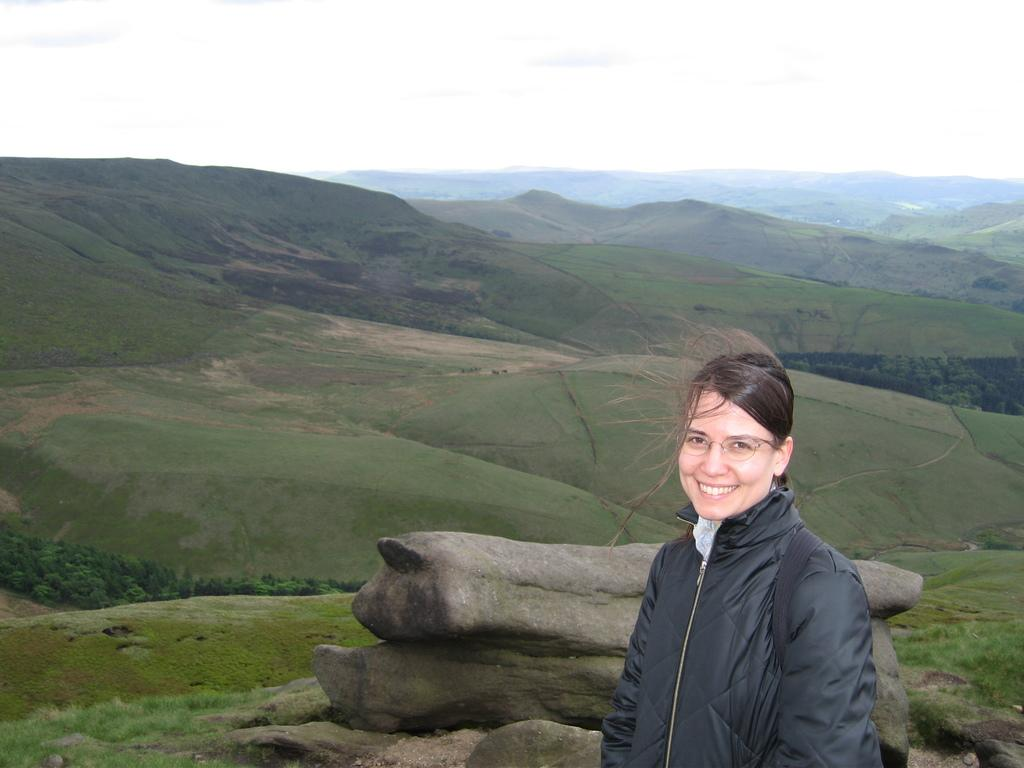Who is present in the image? There is a woman in the image. What is the woman wearing? The woman is wearing a black jacket. What is the woman's facial expression? The woman is smiling. What can be seen in the background of the image? There are rocks, hills, and the sky visible in the background of the image. What type of volleyball game is being played in the image? There is no volleyball game present in the image; it features a woman in a black jacket, smiling, with a background of rocks, hills, and the sky. 